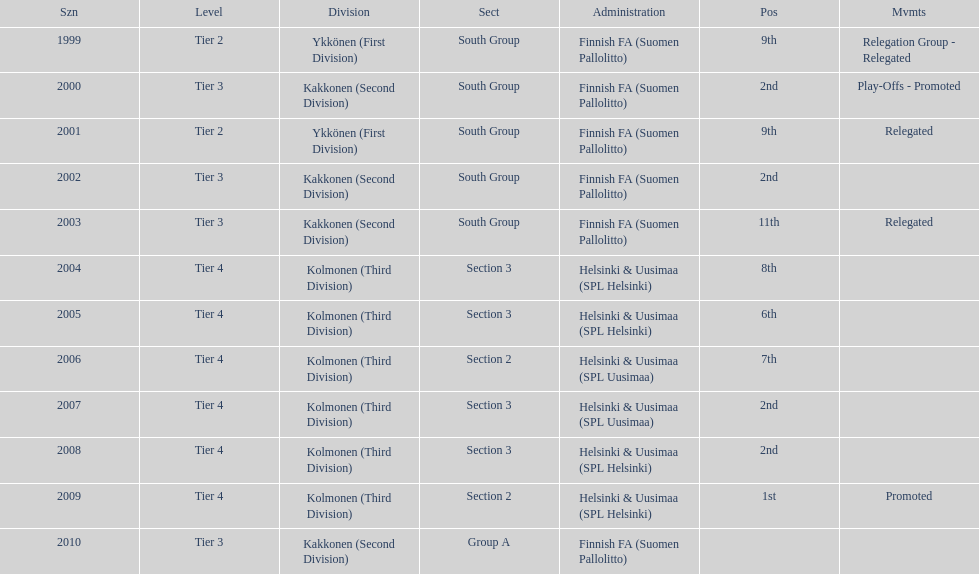Which was the only kolmonen whose movements were promoted? 2009. 